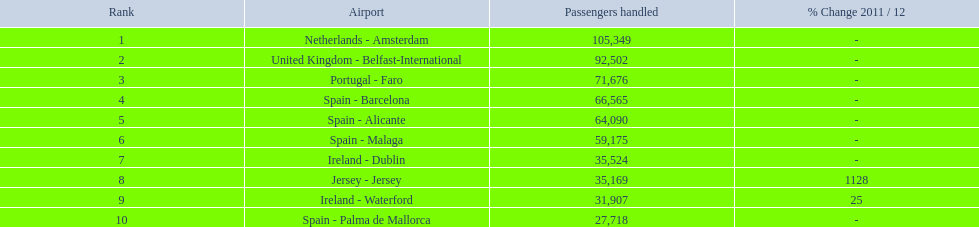How many passengers did the united kingdom handle? 92,502. Who handled more passengers than this? Netherlands - Amsterdam. 